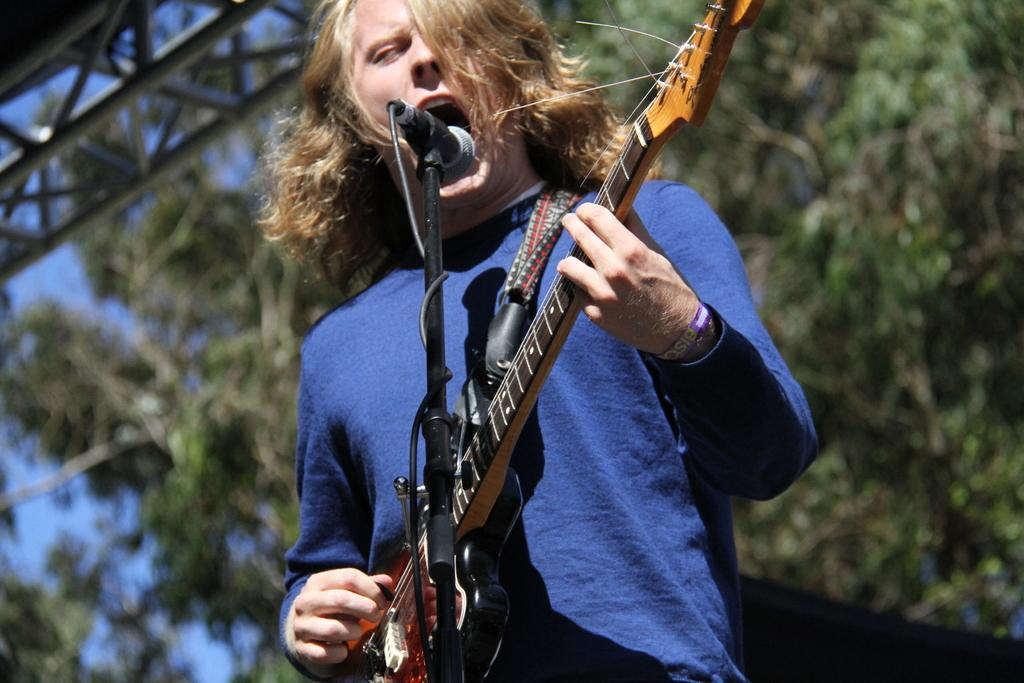What is the person in the image doing? The person is singing. What instrument is the person holding? The person is holding a guitar. What object is in front of the person? There is a microphone in the front of the image. What can be seen in the background of the image? There are trees at the back of the image. How does the person in the image trade with the trees in the background? There is no indication in the image that the person is trading with the trees; they are simply singing and holding a guitar. 